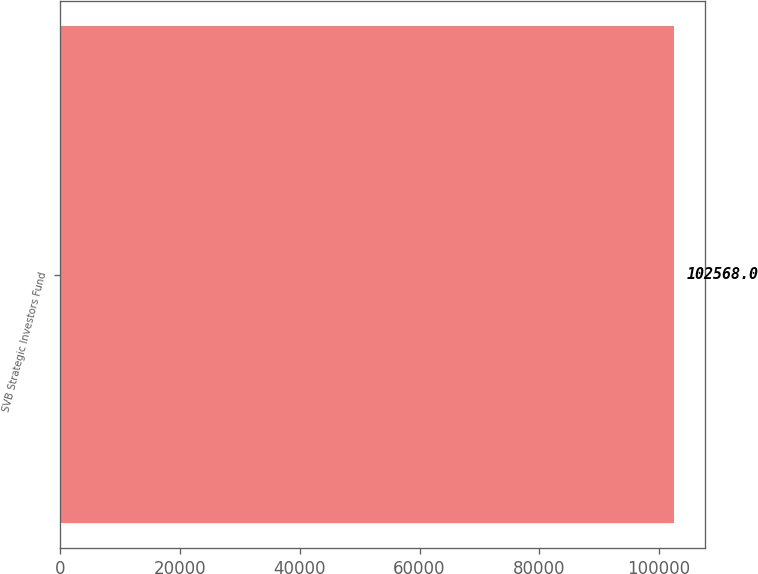<chart> <loc_0><loc_0><loc_500><loc_500><bar_chart><fcel>SVB Strategic Investors Fund<nl><fcel>102568<nl></chart> 